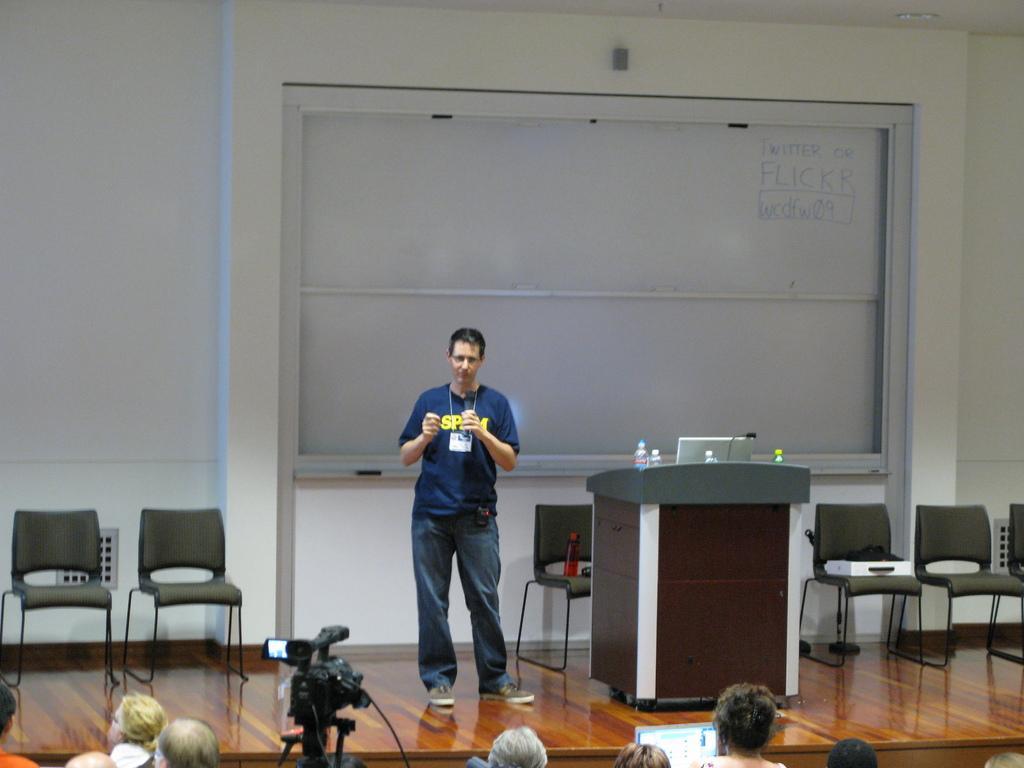In one or two sentences, can you explain what this image depicts? In this image man is standing in the center on the stage. In the background there is a white board with the words written twitter or flickr. On the stage there are empty chairs, podium with the laptop and bottles. In the front there is a camera and crowds. 